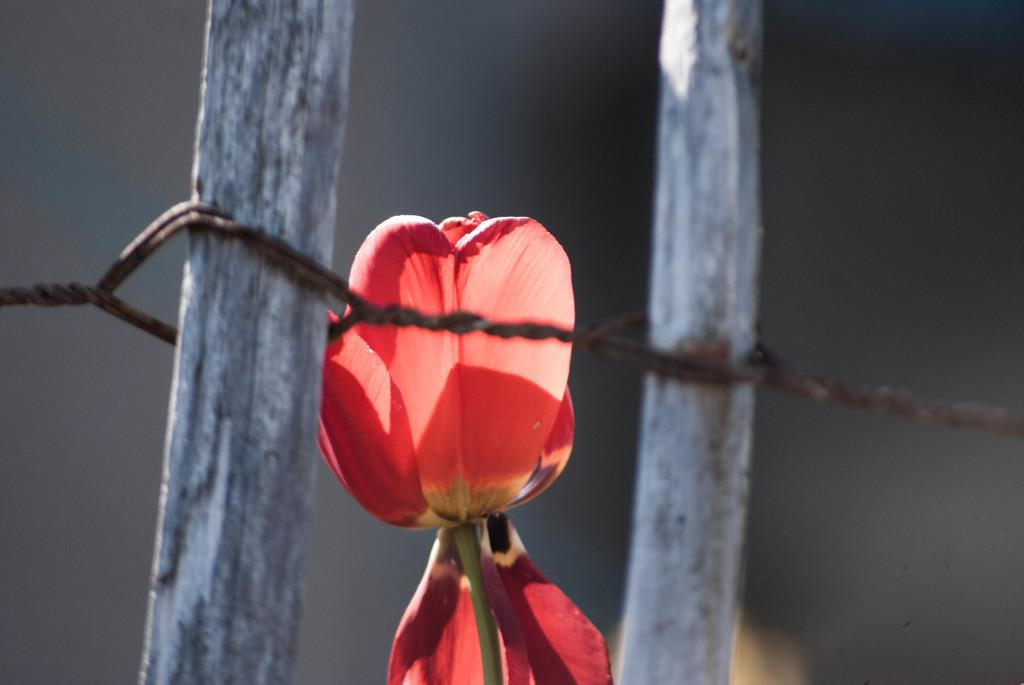What type of flower is in the image? There is a red flower in the image. What objects are made of wood in the image? There are two wooden sticks in the image. What material is the wire made of in the image? The wire in the image is made of metal. How would you describe the background of the image? The background of the image is dark. What book is being read in the image? There is no book present in the image. What type of approval is being given in the image? There is no approval process or decision being depicted in the image. 